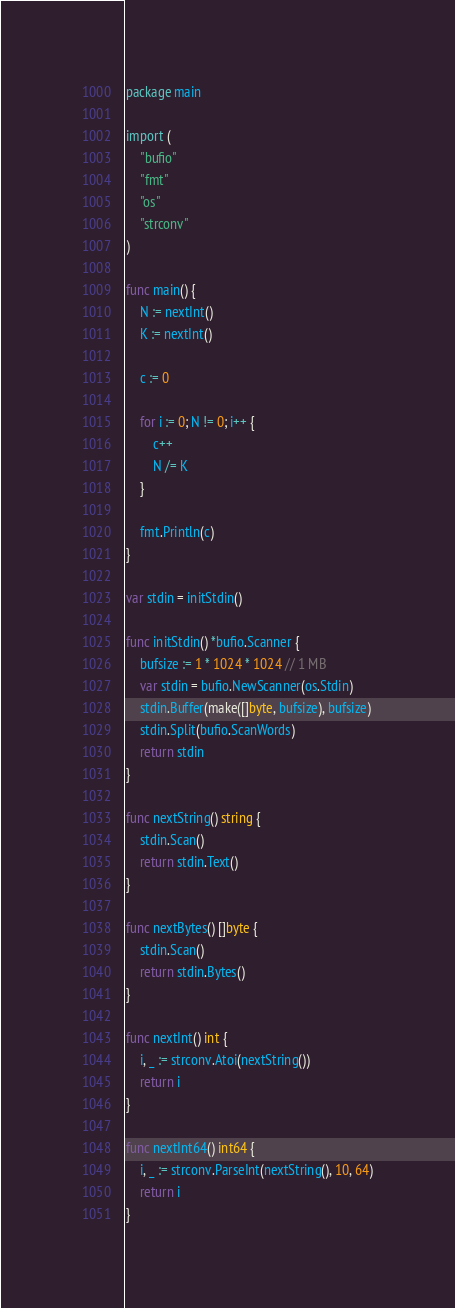<code> <loc_0><loc_0><loc_500><loc_500><_Go_>package main

import (
	"bufio"
	"fmt"
	"os"
	"strconv"
)

func main() {
	N := nextInt()
	K := nextInt()

	c := 0

	for i := 0; N != 0; i++ {
		c++
		N /= K
	}

	fmt.Println(c)
}

var stdin = initStdin()

func initStdin() *bufio.Scanner {
	bufsize := 1 * 1024 * 1024 // 1 MB
	var stdin = bufio.NewScanner(os.Stdin)
	stdin.Buffer(make([]byte, bufsize), bufsize)
	stdin.Split(bufio.ScanWords)
	return stdin
}

func nextString() string {
	stdin.Scan()
	return stdin.Text()
}

func nextBytes() []byte {
	stdin.Scan()
	return stdin.Bytes()
}

func nextInt() int {
	i, _ := strconv.Atoi(nextString())
	return i
}

func nextInt64() int64 {
	i, _ := strconv.ParseInt(nextString(), 10, 64)
	return i
}
</code> 